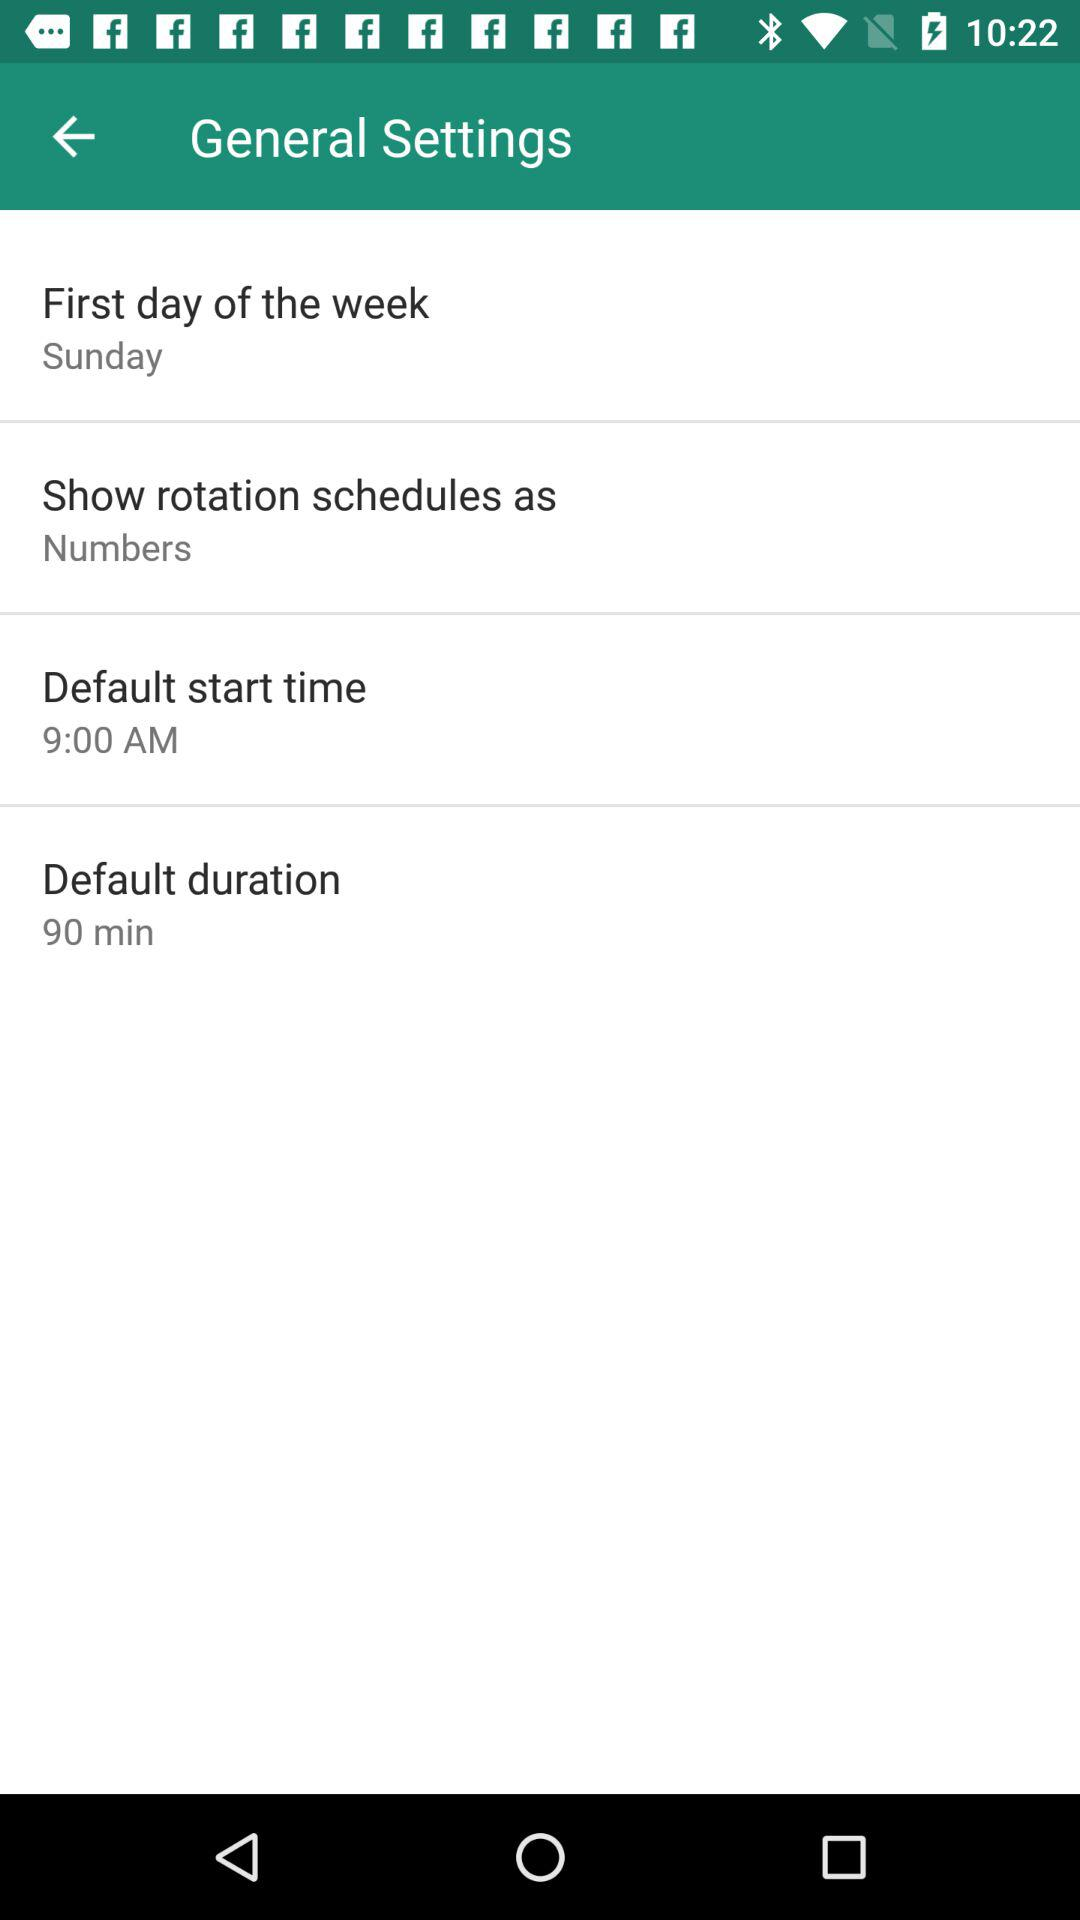What is the setting for the "First day of the week"? The setting is "Sunday". 